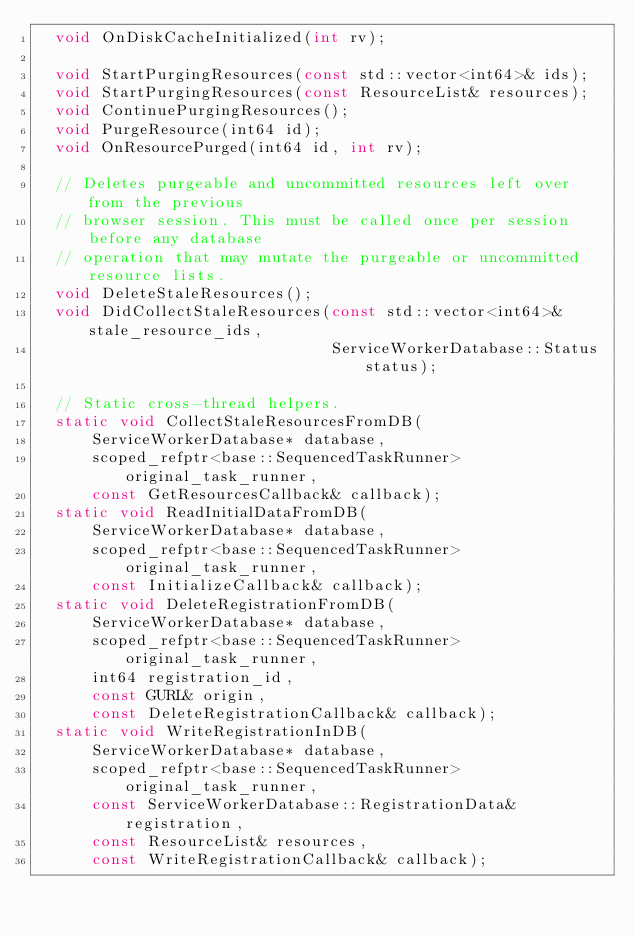Convert code to text. <code><loc_0><loc_0><loc_500><loc_500><_C_>  void OnDiskCacheInitialized(int rv);

  void StartPurgingResources(const std::vector<int64>& ids);
  void StartPurgingResources(const ResourceList& resources);
  void ContinuePurgingResources();
  void PurgeResource(int64 id);
  void OnResourcePurged(int64 id, int rv);

  // Deletes purgeable and uncommitted resources left over from the previous
  // browser session. This must be called once per session before any database
  // operation that may mutate the purgeable or uncommitted resource lists.
  void DeleteStaleResources();
  void DidCollectStaleResources(const std::vector<int64>& stale_resource_ids,
                                ServiceWorkerDatabase::Status status);

  // Static cross-thread helpers.
  static void CollectStaleResourcesFromDB(
      ServiceWorkerDatabase* database,
      scoped_refptr<base::SequencedTaskRunner> original_task_runner,
      const GetResourcesCallback& callback);
  static void ReadInitialDataFromDB(
      ServiceWorkerDatabase* database,
      scoped_refptr<base::SequencedTaskRunner> original_task_runner,
      const InitializeCallback& callback);
  static void DeleteRegistrationFromDB(
      ServiceWorkerDatabase* database,
      scoped_refptr<base::SequencedTaskRunner> original_task_runner,
      int64 registration_id,
      const GURL& origin,
      const DeleteRegistrationCallback& callback);
  static void WriteRegistrationInDB(
      ServiceWorkerDatabase* database,
      scoped_refptr<base::SequencedTaskRunner> original_task_runner,
      const ServiceWorkerDatabase::RegistrationData& registration,
      const ResourceList& resources,
      const WriteRegistrationCallback& callback);</code> 